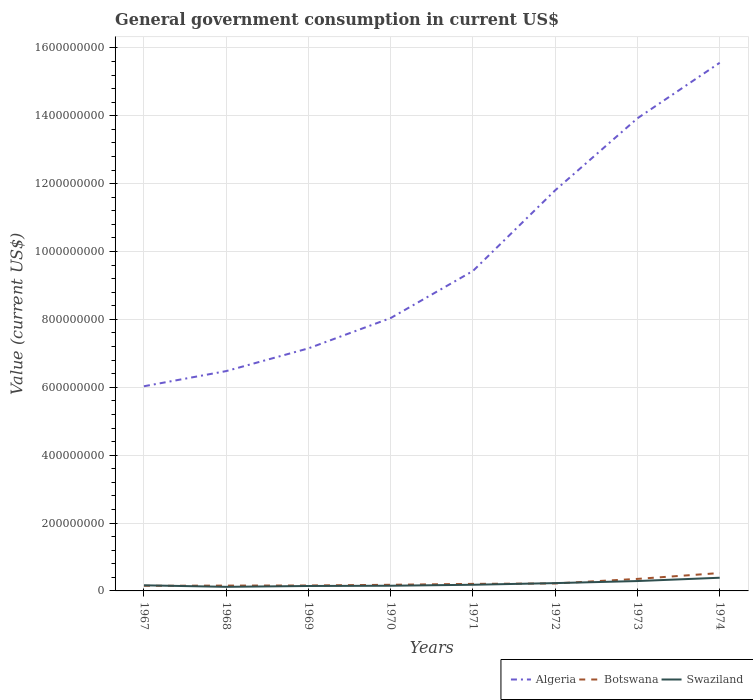How many different coloured lines are there?
Provide a short and direct response. 3. Is the number of lines equal to the number of legend labels?
Make the answer very short. Yes. Across all years, what is the maximum government conusmption in Botswana?
Provide a succinct answer. 1.51e+07. In which year was the government conusmption in Botswana maximum?
Your response must be concise. 1967. What is the total government conusmption in Botswana in the graph?
Ensure brevity in your answer.  -3.96e+06. What is the difference between the highest and the second highest government conusmption in Algeria?
Ensure brevity in your answer.  9.53e+08. How many lines are there?
Make the answer very short. 3. What is the title of the graph?
Ensure brevity in your answer.  General government consumption in current US$. Does "Panama" appear as one of the legend labels in the graph?
Your answer should be compact. No. What is the label or title of the Y-axis?
Provide a short and direct response. Value (current US$). What is the Value (current US$) in Algeria in 1967?
Your answer should be compact. 6.03e+08. What is the Value (current US$) of Botswana in 1967?
Offer a very short reply. 1.51e+07. What is the Value (current US$) of Swaziland in 1967?
Offer a very short reply. 1.65e+07. What is the Value (current US$) of Algeria in 1968?
Your response must be concise. 6.48e+08. What is the Value (current US$) of Botswana in 1968?
Provide a short and direct response. 1.57e+07. What is the Value (current US$) of Swaziland in 1968?
Make the answer very short. 1.20e+07. What is the Value (current US$) in Algeria in 1969?
Your response must be concise. 7.15e+08. What is the Value (current US$) in Botswana in 1969?
Offer a terse response. 1.60e+07. What is the Value (current US$) of Swaziland in 1969?
Make the answer very short. 1.46e+07. What is the Value (current US$) in Algeria in 1970?
Offer a terse response. 8.04e+08. What is the Value (current US$) in Botswana in 1970?
Keep it short and to the point. 1.81e+07. What is the Value (current US$) in Swaziland in 1970?
Provide a short and direct response. 1.53e+07. What is the Value (current US$) in Algeria in 1971?
Give a very brief answer. 9.43e+08. What is the Value (current US$) of Botswana in 1971?
Give a very brief answer. 2.08e+07. What is the Value (current US$) in Swaziland in 1971?
Make the answer very short. 1.82e+07. What is the Value (current US$) of Algeria in 1972?
Your answer should be very brief. 1.18e+09. What is the Value (current US$) in Botswana in 1972?
Give a very brief answer. 2.20e+07. What is the Value (current US$) in Swaziland in 1972?
Make the answer very short. 2.30e+07. What is the Value (current US$) in Algeria in 1973?
Offer a terse response. 1.39e+09. What is the Value (current US$) in Botswana in 1973?
Provide a succinct answer. 3.54e+07. What is the Value (current US$) of Swaziland in 1973?
Ensure brevity in your answer.  2.91e+07. What is the Value (current US$) in Algeria in 1974?
Give a very brief answer. 1.56e+09. What is the Value (current US$) of Botswana in 1974?
Give a very brief answer. 5.27e+07. What is the Value (current US$) in Swaziland in 1974?
Offer a terse response. 3.89e+07. Across all years, what is the maximum Value (current US$) of Algeria?
Your answer should be very brief. 1.56e+09. Across all years, what is the maximum Value (current US$) in Botswana?
Give a very brief answer. 5.27e+07. Across all years, what is the maximum Value (current US$) in Swaziland?
Keep it short and to the point. 3.89e+07. Across all years, what is the minimum Value (current US$) in Algeria?
Offer a very short reply. 6.03e+08. Across all years, what is the minimum Value (current US$) in Botswana?
Ensure brevity in your answer.  1.51e+07. Across all years, what is the minimum Value (current US$) of Swaziland?
Offer a very short reply. 1.20e+07. What is the total Value (current US$) in Algeria in the graph?
Ensure brevity in your answer.  7.84e+09. What is the total Value (current US$) in Botswana in the graph?
Give a very brief answer. 1.96e+08. What is the total Value (current US$) in Swaziland in the graph?
Provide a short and direct response. 1.68e+08. What is the difference between the Value (current US$) in Algeria in 1967 and that in 1968?
Provide a short and direct response. -4.47e+07. What is the difference between the Value (current US$) of Botswana in 1967 and that in 1968?
Keep it short and to the point. -5.59e+05. What is the difference between the Value (current US$) in Swaziland in 1967 and that in 1968?
Offer a terse response. 4.48e+06. What is the difference between the Value (current US$) in Algeria in 1967 and that in 1969?
Your answer should be very brief. -1.12e+08. What is the difference between the Value (current US$) of Botswana in 1967 and that in 1969?
Keep it short and to the point. -8.84e+05. What is the difference between the Value (current US$) in Swaziland in 1967 and that in 1969?
Make the answer very short. 1.96e+06. What is the difference between the Value (current US$) in Algeria in 1967 and that in 1970?
Ensure brevity in your answer.  -2.01e+08. What is the difference between the Value (current US$) of Botswana in 1967 and that in 1970?
Ensure brevity in your answer.  -2.94e+06. What is the difference between the Value (current US$) in Swaziland in 1967 and that in 1970?
Make the answer very short. 1.26e+06. What is the difference between the Value (current US$) of Algeria in 1967 and that in 1971?
Your answer should be very brief. -3.40e+08. What is the difference between the Value (current US$) of Botswana in 1967 and that in 1971?
Give a very brief answer. -5.63e+06. What is the difference between the Value (current US$) in Swaziland in 1967 and that in 1971?
Give a very brief answer. -1.66e+06. What is the difference between the Value (current US$) of Algeria in 1967 and that in 1972?
Offer a terse response. -5.77e+08. What is the difference between the Value (current US$) of Botswana in 1967 and that in 1972?
Ensure brevity in your answer.  -6.91e+06. What is the difference between the Value (current US$) of Swaziland in 1967 and that in 1972?
Provide a short and direct response. -6.51e+06. What is the difference between the Value (current US$) of Algeria in 1967 and that in 1973?
Make the answer very short. -7.90e+08. What is the difference between the Value (current US$) of Botswana in 1967 and that in 1973?
Offer a terse response. -2.03e+07. What is the difference between the Value (current US$) of Swaziland in 1967 and that in 1973?
Ensure brevity in your answer.  -1.26e+07. What is the difference between the Value (current US$) in Algeria in 1967 and that in 1974?
Make the answer very short. -9.53e+08. What is the difference between the Value (current US$) in Botswana in 1967 and that in 1974?
Keep it short and to the point. -3.76e+07. What is the difference between the Value (current US$) of Swaziland in 1967 and that in 1974?
Offer a very short reply. -2.23e+07. What is the difference between the Value (current US$) of Algeria in 1968 and that in 1969?
Keep it short and to the point. -6.70e+07. What is the difference between the Value (current US$) in Botswana in 1968 and that in 1969?
Keep it short and to the point. -3.25e+05. What is the difference between the Value (current US$) of Swaziland in 1968 and that in 1969?
Your answer should be very brief. -2.52e+06. What is the difference between the Value (current US$) of Algeria in 1968 and that in 1970?
Your answer should be very brief. -1.56e+08. What is the difference between the Value (current US$) of Botswana in 1968 and that in 1970?
Your answer should be compact. -2.39e+06. What is the difference between the Value (current US$) in Swaziland in 1968 and that in 1970?
Keep it short and to the point. -3.22e+06. What is the difference between the Value (current US$) of Algeria in 1968 and that in 1971?
Provide a short and direct response. -2.95e+08. What is the difference between the Value (current US$) in Botswana in 1968 and that in 1971?
Your response must be concise. -5.07e+06. What is the difference between the Value (current US$) in Swaziland in 1968 and that in 1971?
Make the answer very short. -6.14e+06. What is the difference between the Value (current US$) in Algeria in 1968 and that in 1972?
Provide a short and direct response. -5.33e+08. What is the difference between the Value (current US$) in Botswana in 1968 and that in 1972?
Ensure brevity in your answer.  -6.35e+06. What is the difference between the Value (current US$) of Swaziland in 1968 and that in 1972?
Your answer should be very brief. -1.10e+07. What is the difference between the Value (current US$) in Algeria in 1968 and that in 1973?
Your answer should be very brief. -7.45e+08. What is the difference between the Value (current US$) in Botswana in 1968 and that in 1973?
Give a very brief answer. -1.98e+07. What is the difference between the Value (current US$) of Swaziland in 1968 and that in 1973?
Your response must be concise. -1.71e+07. What is the difference between the Value (current US$) in Algeria in 1968 and that in 1974?
Provide a short and direct response. -9.08e+08. What is the difference between the Value (current US$) in Botswana in 1968 and that in 1974?
Your answer should be compact. -3.70e+07. What is the difference between the Value (current US$) of Swaziland in 1968 and that in 1974?
Offer a very short reply. -2.68e+07. What is the difference between the Value (current US$) in Algeria in 1969 and that in 1970?
Ensure brevity in your answer.  -8.93e+07. What is the difference between the Value (current US$) in Botswana in 1969 and that in 1970?
Offer a terse response. -2.06e+06. What is the difference between the Value (current US$) of Swaziland in 1969 and that in 1970?
Give a very brief answer. -7.00e+05. What is the difference between the Value (current US$) in Algeria in 1969 and that in 1971?
Provide a short and direct response. -2.28e+08. What is the difference between the Value (current US$) of Botswana in 1969 and that in 1971?
Offer a very short reply. -4.75e+06. What is the difference between the Value (current US$) in Swaziland in 1969 and that in 1971?
Your response must be concise. -3.62e+06. What is the difference between the Value (current US$) in Algeria in 1969 and that in 1972?
Give a very brief answer. -4.66e+08. What is the difference between the Value (current US$) in Botswana in 1969 and that in 1972?
Offer a very short reply. -6.02e+06. What is the difference between the Value (current US$) in Swaziland in 1969 and that in 1972?
Give a very brief answer. -8.47e+06. What is the difference between the Value (current US$) of Algeria in 1969 and that in 1973?
Make the answer very short. -6.78e+08. What is the difference between the Value (current US$) of Botswana in 1969 and that in 1973?
Offer a terse response. -1.94e+07. What is the difference between the Value (current US$) in Swaziland in 1969 and that in 1973?
Your response must be concise. -1.45e+07. What is the difference between the Value (current US$) of Algeria in 1969 and that in 1974?
Offer a terse response. -8.41e+08. What is the difference between the Value (current US$) in Botswana in 1969 and that in 1974?
Offer a terse response. -3.67e+07. What is the difference between the Value (current US$) in Swaziland in 1969 and that in 1974?
Provide a succinct answer. -2.43e+07. What is the difference between the Value (current US$) in Algeria in 1970 and that in 1971?
Make the answer very short. -1.39e+08. What is the difference between the Value (current US$) of Botswana in 1970 and that in 1971?
Make the answer very short. -2.69e+06. What is the difference between the Value (current US$) of Swaziland in 1970 and that in 1971?
Provide a short and direct response. -2.92e+06. What is the difference between the Value (current US$) in Algeria in 1970 and that in 1972?
Offer a very short reply. -3.76e+08. What is the difference between the Value (current US$) in Botswana in 1970 and that in 1972?
Offer a very short reply. -3.96e+06. What is the difference between the Value (current US$) of Swaziland in 1970 and that in 1972?
Provide a short and direct response. -7.77e+06. What is the difference between the Value (current US$) of Algeria in 1970 and that in 1973?
Keep it short and to the point. -5.89e+08. What is the difference between the Value (current US$) of Botswana in 1970 and that in 1973?
Give a very brief answer. -1.74e+07. What is the difference between the Value (current US$) in Swaziland in 1970 and that in 1973?
Ensure brevity in your answer.  -1.38e+07. What is the difference between the Value (current US$) of Algeria in 1970 and that in 1974?
Your answer should be compact. -7.52e+08. What is the difference between the Value (current US$) of Botswana in 1970 and that in 1974?
Give a very brief answer. -3.46e+07. What is the difference between the Value (current US$) in Swaziland in 1970 and that in 1974?
Ensure brevity in your answer.  -2.36e+07. What is the difference between the Value (current US$) in Algeria in 1971 and that in 1972?
Provide a short and direct response. -2.38e+08. What is the difference between the Value (current US$) of Botswana in 1971 and that in 1972?
Your response must be concise. -1.28e+06. What is the difference between the Value (current US$) in Swaziland in 1971 and that in 1972?
Offer a terse response. -4.85e+06. What is the difference between the Value (current US$) of Algeria in 1971 and that in 1973?
Your answer should be compact. -4.50e+08. What is the difference between the Value (current US$) of Botswana in 1971 and that in 1973?
Give a very brief answer. -1.47e+07. What is the difference between the Value (current US$) in Swaziland in 1971 and that in 1973?
Give a very brief answer. -1.09e+07. What is the difference between the Value (current US$) in Algeria in 1971 and that in 1974?
Ensure brevity in your answer.  -6.13e+08. What is the difference between the Value (current US$) in Botswana in 1971 and that in 1974?
Your response must be concise. -3.19e+07. What is the difference between the Value (current US$) in Swaziland in 1971 and that in 1974?
Ensure brevity in your answer.  -2.07e+07. What is the difference between the Value (current US$) in Algeria in 1972 and that in 1973?
Keep it short and to the point. -2.12e+08. What is the difference between the Value (current US$) in Botswana in 1972 and that in 1973?
Your response must be concise. -1.34e+07. What is the difference between the Value (current US$) in Swaziland in 1972 and that in 1973?
Keep it short and to the point. -6.08e+06. What is the difference between the Value (current US$) in Algeria in 1972 and that in 1974?
Your answer should be compact. -3.76e+08. What is the difference between the Value (current US$) of Botswana in 1972 and that in 1974?
Give a very brief answer. -3.06e+07. What is the difference between the Value (current US$) of Swaziland in 1972 and that in 1974?
Your answer should be compact. -1.58e+07. What is the difference between the Value (current US$) in Algeria in 1973 and that in 1974?
Keep it short and to the point. -1.64e+08. What is the difference between the Value (current US$) of Botswana in 1973 and that in 1974?
Keep it short and to the point. -1.72e+07. What is the difference between the Value (current US$) in Swaziland in 1973 and that in 1974?
Offer a very short reply. -9.75e+06. What is the difference between the Value (current US$) in Algeria in 1967 and the Value (current US$) in Botswana in 1968?
Your answer should be compact. 5.87e+08. What is the difference between the Value (current US$) in Algeria in 1967 and the Value (current US$) in Swaziland in 1968?
Ensure brevity in your answer.  5.91e+08. What is the difference between the Value (current US$) of Botswana in 1967 and the Value (current US$) of Swaziland in 1968?
Your answer should be compact. 3.09e+06. What is the difference between the Value (current US$) of Algeria in 1967 and the Value (current US$) of Botswana in 1969?
Make the answer very short. 5.87e+08. What is the difference between the Value (current US$) in Algeria in 1967 and the Value (current US$) in Swaziland in 1969?
Provide a short and direct response. 5.88e+08. What is the difference between the Value (current US$) of Botswana in 1967 and the Value (current US$) of Swaziland in 1969?
Your response must be concise. 5.71e+05. What is the difference between the Value (current US$) in Algeria in 1967 and the Value (current US$) in Botswana in 1970?
Keep it short and to the point. 5.85e+08. What is the difference between the Value (current US$) in Algeria in 1967 and the Value (current US$) in Swaziland in 1970?
Offer a terse response. 5.88e+08. What is the difference between the Value (current US$) in Botswana in 1967 and the Value (current US$) in Swaziland in 1970?
Ensure brevity in your answer.  -1.29e+05. What is the difference between the Value (current US$) of Algeria in 1967 and the Value (current US$) of Botswana in 1971?
Provide a succinct answer. 5.82e+08. What is the difference between the Value (current US$) of Algeria in 1967 and the Value (current US$) of Swaziland in 1971?
Make the answer very short. 5.85e+08. What is the difference between the Value (current US$) of Botswana in 1967 and the Value (current US$) of Swaziland in 1971?
Provide a short and direct response. -3.04e+06. What is the difference between the Value (current US$) in Algeria in 1967 and the Value (current US$) in Botswana in 1972?
Give a very brief answer. 5.81e+08. What is the difference between the Value (current US$) of Algeria in 1967 and the Value (current US$) of Swaziland in 1972?
Your response must be concise. 5.80e+08. What is the difference between the Value (current US$) in Botswana in 1967 and the Value (current US$) in Swaziland in 1972?
Provide a short and direct response. -7.89e+06. What is the difference between the Value (current US$) in Algeria in 1967 and the Value (current US$) in Botswana in 1973?
Your response must be concise. 5.68e+08. What is the difference between the Value (current US$) of Algeria in 1967 and the Value (current US$) of Swaziland in 1973?
Provide a short and direct response. 5.74e+08. What is the difference between the Value (current US$) in Botswana in 1967 and the Value (current US$) in Swaziland in 1973?
Give a very brief answer. -1.40e+07. What is the difference between the Value (current US$) of Algeria in 1967 and the Value (current US$) of Botswana in 1974?
Provide a succinct answer. 5.50e+08. What is the difference between the Value (current US$) in Algeria in 1967 and the Value (current US$) in Swaziland in 1974?
Your response must be concise. 5.64e+08. What is the difference between the Value (current US$) of Botswana in 1967 and the Value (current US$) of Swaziland in 1974?
Your answer should be very brief. -2.37e+07. What is the difference between the Value (current US$) in Algeria in 1968 and the Value (current US$) in Botswana in 1969?
Offer a terse response. 6.32e+08. What is the difference between the Value (current US$) in Algeria in 1968 and the Value (current US$) in Swaziland in 1969?
Your answer should be very brief. 6.33e+08. What is the difference between the Value (current US$) of Botswana in 1968 and the Value (current US$) of Swaziland in 1969?
Offer a very short reply. 1.13e+06. What is the difference between the Value (current US$) in Algeria in 1968 and the Value (current US$) in Botswana in 1970?
Provide a short and direct response. 6.30e+08. What is the difference between the Value (current US$) in Algeria in 1968 and the Value (current US$) in Swaziland in 1970?
Offer a very short reply. 6.32e+08. What is the difference between the Value (current US$) in Botswana in 1968 and the Value (current US$) in Swaziland in 1970?
Offer a very short reply. 4.30e+05. What is the difference between the Value (current US$) of Algeria in 1968 and the Value (current US$) of Botswana in 1971?
Your response must be concise. 6.27e+08. What is the difference between the Value (current US$) of Algeria in 1968 and the Value (current US$) of Swaziland in 1971?
Your answer should be very brief. 6.30e+08. What is the difference between the Value (current US$) of Botswana in 1968 and the Value (current US$) of Swaziland in 1971?
Provide a short and direct response. -2.49e+06. What is the difference between the Value (current US$) of Algeria in 1968 and the Value (current US$) of Botswana in 1972?
Make the answer very short. 6.26e+08. What is the difference between the Value (current US$) in Algeria in 1968 and the Value (current US$) in Swaziland in 1972?
Your answer should be compact. 6.25e+08. What is the difference between the Value (current US$) of Botswana in 1968 and the Value (current US$) of Swaziland in 1972?
Your answer should be compact. -7.34e+06. What is the difference between the Value (current US$) in Algeria in 1968 and the Value (current US$) in Botswana in 1973?
Your answer should be compact. 6.12e+08. What is the difference between the Value (current US$) of Algeria in 1968 and the Value (current US$) of Swaziland in 1973?
Your response must be concise. 6.19e+08. What is the difference between the Value (current US$) of Botswana in 1968 and the Value (current US$) of Swaziland in 1973?
Provide a short and direct response. -1.34e+07. What is the difference between the Value (current US$) in Algeria in 1968 and the Value (current US$) in Botswana in 1974?
Keep it short and to the point. 5.95e+08. What is the difference between the Value (current US$) in Algeria in 1968 and the Value (current US$) in Swaziland in 1974?
Your answer should be compact. 6.09e+08. What is the difference between the Value (current US$) in Botswana in 1968 and the Value (current US$) in Swaziland in 1974?
Make the answer very short. -2.32e+07. What is the difference between the Value (current US$) in Algeria in 1969 and the Value (current US$) in Botswana in 1970?
Ensure brevity in your answer.  6.97e+08. What is the difference between the Value (current US$) of Algeria in 1969 and the Value (current US$) of Swaziland in 1970?
Make the answer very short. 6.99e+08. What is the difference between the Value (current US$) of Botswana in 1969 and the Value (current US$) of Swaziland in 1970?
Keep it short and to the point. 7.55e+05. What is the difference between the Value (current US$) of Algeria in 1969 and the Value (current US$) of Botswana in 1971?
Make the answer very short. 6.94e+08. What is the difference between the Value (current US$) in Algeria in 1969 and the Value (current US$) in Swaziland in 1971?
Give a very brief answer. 6.97e+08. What is the difference between the Value (current US$) in Botswana in 1969 and the Value (current US$) in Swaziland in 1971?
Provide a short and direct response. -2.16e+06. What is the difference between the Value (current US$) in Algeria in 1969 and the Value (current US$) in Botswana in 1972?
Your answer should be very brief. 6.93e+08. What is the difference between the Value (current US$) in Algeria in 1969 and the Value (current US$) in Swaziland in 1972?
Offer a terse response. 6.92e+08. What is the difference between the Value (current US$) of Botswana in 1969 and the Value (current US$) of Swaziland in 1972?
Offer a very short reply. -7.01e+06. What is the difference between the Value (current US$) in Algeria in 1969 and the Value (current US$) in Botswana in 1973?
Keep it short and to the point. 6.79e+08. What is the difference between the Value (current US$) in Algeria in 1969 and the Value (current US$) in Swaziland in 1973?
Ensure brevity in your answer.  6.86e+08. What is the difference between the Value (current US$) of Botswana in 1969 and the Value (current US$) of Swaziland in 1973?
Offer a very short reply. -1.31e+07. What is the difference between the Value (current US$) of Algeria in 1969 and the Value (current US$) of Botswana in 1974?
Your answer should be compact. 6.62e+08. What is the difference between the Value (current US$) of Algeria in 1969 and the Value (current US$) of Swaziland in 1974?
Offer a terse response. 6.76e+08. What is the difference between the Value (current US$) in Botswana in 1969 and the Value (current US$) in Swaziland in 1974?
Keep it short and to the point. -2.28e+07. What is the difference between the Value (current US$) of Algeria in 1970 and the Value (current US$) of Botswana in 1971?
Your answer should be very brief. 7.83e+08. What is the difference between the Value (current US$) of Algeria in 1970 and the Value (current US$) of Swaziland in 1971?
Offer a terse response. 7.86e+08. What is the difference between the Value (current US$) of Botswana in 1970 and the Value (current US$) of Swaziland in 1971?
Provide a succinct answer. -1.00e+05. What is the difference between the Value (current US$) of Algeria in 1970 and the Value (current US$) of Botswana in 1972?
Give a very brief answer. 7.82e+08. What is the difference between the Value (current US$) in Algeria in 1970 and the Value (current US$) in Swaziland in 1972?
Provide a short and direct response. 7.81e+08. What is the difference between the Value (current US$) of Botswana in 1970 and the Value (current US$) of Swaziland in 1972?
Your answer should be compact. -4.95e+06. What is the difference between the Value (current US$) of Algeria in 1970 and the Value (current US$) of Botswana in 1973?
Make the answer very short. 7.69e+08. What is the difference between the Value (current US$) of Algeria in 1970 and the Value (current US$) of Swaziland in 1973?
Ensure brevity in your answer.  7.75e+08. What is the difference between the Value (current US$) in Botswana in 1970 and the Value (current US$) in Swaziland in 1973?
Keep it short and to the point. -1.10e+07. What is the difference between the Value (current US$) of Algeria in 1970 and the Value (current US$) of Botswana in 1974?
Ensure brevity in your answer.  7.51e+08. What is the difference between the Value (current US$) of Algeria in 1970 and the Value (current US$) of Swaziland in 1974?
Give a very brief answer. 7.65e+08. What is the difference between the Value (current US$) of Botswana in 1970 and the Value (current US$) of Swaziland in 1974?
Give a very brief answer. -2.08e+07. What is the difference between the Value (current US$) in Algeria in 1971 and the Value (current US$) in Botswana in 1972?
Offer a very short reply. 9.21e+08. What is the difference between the Value (current US$) in Algeria in 1971 and the Value (current US$) in Swaziland in 1972?
Offer a terse response. 9.20e+08. What is the difference between the Value (current US$) of Botswana in 1971 and the Value (current US$) of Swaziland in 1972?
Ensure brevity in your answer.  -2.26e+06. What is the difference between the Value (current US$) of Algeria in 1971 and the Value (current US$) of Botswana in 1973?
Ensure brevity in your answer.  9.07e+08. What is the difference between the Value (current US$) of Algeria in 1971 and the Value (current US$) of Swaziland in 1973?
Provide a succinct answer. 9.14e+08. What is the difference between the Value (current US$) in Botswana in 1971 and the Value (current US$) in Swaziland in 1973?
Make the answer very short. -8.35e+06. What is the difference between the Value (current US$) of Algeria in 1971 and the Value (current US$) of Botswana in 1974?
Offer a terse response. 8.90e+08. What is the difference between the Value (current US$) in Algeria in 1971 and the Value (current US$) in Swaziland in 1974?
Keep it short and to the point. 9.04e+08. What is the difference between the Value (current US$) of Botswana in 1971 and the Value (current US$) of Swaziland in 1974?
Keep it short and to the point. -1.81e+07. What is the difference between the Value (current US$) of Algeria in 1972 and the Value (current US$) of Botswana in 1973?
Your answer should be compact. 1.14e+09. What is the difference between the Value (current US$) of Algeria in 1972 and the Value (current US$) of Swaziland in 1973?
Ensure brevity in your answer.  1.15e+09. What is the difference between the Value (current US$) of Botswana in 1972 and the Value (current US$) of Swaziland in 1973?
Give a very brief answer. -7.07e+06. What is the difference between the Value (current US$) in Algeria in 1972 and the Value (current US$) in Botswana in 1974?
Make the answer very short. 1.13e+09. What is the difference between the Value (current US$) in Algeria in 1972 and the Value (current US$) in Swaziland in 1974?
Your answer should be very brief. 1.14e+09. What is the difference between the Value (current US$) in Botswana in 1972 and the Value (current US$) in Swaziland in 1974?
Offer a terse response. -1.68e+07. What is the difference between the Value (current US$) of Algeria in 1973 and the Value (current US$) of Botswana in 1974?
Give a very brief answer. 1.34e+09. What is the difference between the Value (current US$) of Algeria in 1973 and the Value (current US$) of Swaziland in 1974?
Provide a short and direct response. 1.35e+09. What is the difference between the Value (current US$) in Botswana in 1973 and the Value (current US$) in Swaziland in 1974?
Provide a succinct answer. -3.41e+06. What is the average Value (current US$) in Algeria per year?
Keep it short and to the point. 9.80e+08. What is the average Value (current US$) of Botswana per year?
Your response must be concise. 2.45e+07. What is the average Value (current US$) in Swaziland per year?
Your answer should be very brief. 2.09e+07. In the year 1967, what is the difference between the Value (current US$) in Algeria and Value (current US$) in Botswana?
Provide a succinct answer. 5.88e+08. In the year 1967, what is the difference between the Value (current US$) of Algeria and Value (current US$) of Swaziland?
Give a very brief answer. 5.87e+08. In the year 1967, what is the difference between the Value (current US$) in Botswana and Value (current US$) in Swaziland?
Offer a very short reply. -1.39e+06. In the year 1968, what is the difference between the Value (current US$) of Algeria and Value (current US$) of Botswana?
Your answer should be very brief. 6.32e+08. In the year 1968, what is the difference between the Value (current US$) of Algeria and Value (current US$) of Swaziland?
Provide a succinct answer. 6.36e+08. In the year 1968, what is the difference between the Value (current US$) of Botswana and Value (current US$) of Swaziland?
Offer a very short reply. 3.65e+06. In the year 1969, what is the difference between the Value (current US$) of Algeria and Value (current US$) of Botswana?
Offer a terse response. 6.99e+08. In the year 1969, what is the difference between the Value (current US$) in Algeria and Value (current US$) in Swaziland?
Offer a very short reply. 7.00e+08. In the year 1969, what is the difference between the Value (current US$) in Botswana and Value (current US$) in Swaziland?
Offer a terse response. 1.46e+06. In the year 1970, what is the difference between the Value (current US$) in Algeria and Value (current US$) in Botswana?
Give a very brief answer. 7.86e+08. In the year 1970, what is the difference between the Value (current US$) in Algeria and Value (current US$) in Swaziland?
Offer a terse response. 7.89e+08. In the year 1970, what is the difference between the Value (current US$) of Botswana and Value (current US$) of Swaziland?
Provide a succinct answer. 2.82e+06. In the year 1971, what is the difference between the Value (current US$) of Algeria and Value (current US$) of Botswana?
Give a very brief answer. 9.22e+08. In the year 1971, what is the difference between the Value (current US$) in Algeria and Value (current US$) in Swaziland?
Ensure brevity in your answer.  9.25e+08. In the year 1971, what is the difference between the Value (current US$) of Botswana and Value (current US$) of Swaziland?
Your response must be concise. 2.59e+06. In the year 1972, what is the difference between the Value (current US$) of Algeria and Value (current US$) of Botswana?
Your answer should be very brief. 1.16e+09. In the year 1972, what is the difference between the Value (current US$) in Algeria and Value (current US$) in Swaziland?
Offer a very short reply. 1.16e+09. In the year 1972, what is the difference between the Value (current US$) in Botswana and Value (current US$) in Swaziland?
Give a very brief answer. -9.88e+05. In the year 1973, what is the difference between the Value (current US$) of Algeria and Value (current US$) of Botswana?
Ensure brevity in your answer.  1.36e+09. In the year 1973, what is the difference between the Value (current US$) in Algeria and Value (current US$) in Swaziland?
Your answer should be compact. 1.36e+09. In the year 1973, what is the difference between the Value (current US$) in Botswana and Value (current US$) in Swaziland?
Ensure brevity in your answer.  6.33e+06. In the year 1974, what is the difference between the Value (current US$) in Algeria and Value (current US$) in Botswana?
Your response must be concise. 1.50e+09. In the year 1974, what is the difference between the Value (current US$) of Algeria and Value (current US$) of Swaziland?
Your answer should be very brief. 1.52e+09. In the year 1974, what is the difference between the Value (current US$) of Botswana and Value (current US$) of Swaziland?
Ensure brevity in your answer.  1.38e+07. What is the ratio of the Value (current US$) in Botswana in 1967 to that in 1968?
Give a very brief answer. 0.96. What is the ratio of the Value (current US$) in Swaziland in 1967 to that in 1968?
Your answer should be very brief. 1.37. What is the ratio of the Value (current US$) of Algeria in 1967 to that in 1969?
Ensure brevity in your answer.  0.84. What is the ratio of the Value (current US$) of Botswana in 1967 to that in 1969?
Your answer should be compact. 0.94. What is the ratio of the Value (current US$) of Swaziland in 1967 to that in 1969?
Your answer should be compact. 1.13. What is the ratio of the Value (current US$) of Botswana in 1967 to that in 1970?
Give a very brief answer. 0.84. What is the ratio of the Value (current US$) of Swaziland in 1967 to that in 1970?
Your response must be concise. 1.08. What is the ratio of the Value (current US$) in Algeria in 1967 to that in 1971?
Give a very brief answer. 0.64. What is the ratio of the Value (current US$) in Botswana in 1967 to that in 1971?
Offer a terse response. 0.73. What is the ratio of the Value (current US$) in Swaziland in 1967 to that in 1971?
Offer a terse response. 0.91. What is the ratio of the Value (current US$) in Algeria in 1967 to that in 1972?
Make the answer very short. 0.51. What is the ratio of the Value (current US$) of Botswana in 1967 to that in 1972?
Give a very brief answer. 0.69. What is the ratio of the Value (current US$) of Swaziland in 1967 to that in 1972?
Offer a very short reply. 0.72. What is the ratio of the Value (current US$) in Algeria in 1967 to that in 1973?
Provide a short and direct response. 0.43. What is the ratio of the Value (current US$) of Botswana in 1967 to that in 1973?
Keep it short and to the point. 0.43. What is the ratio of the Value (current US$) of Swaziland in 1967 to that in 1973?
Your answer should be very brief. 0.57. What is the ratio of the Value (current US$) in Algeria in 1967 to that in 1974?
Offer a very short reply. 0.39. What is the ratio of the Value (current US$) of Botswana in 1967 to that in 1974?
Ensure brevity in your answer.  0.29. What is the ratio of the Value (current US$) of Swaziland in 1967 to that in 1974?
Give a very brief answer. 0.43. What is the ratio of the Value (current US$) of Algeria in 1968 to that in 1969?
Your answer should be compact. 0.91. What is the ratio of the Value (current US$) in Botswana in 1968 to that in 1969?
Your answer should be compact. 0.98. What is the ratio of the Value (current US$) of Swaziland in 1968 to that in 1969?
Provide a short and direct response. 0.83. What is the ratio of the Value (current US$) in Algeria in 1968 to that in 1970?
Ensure brevity in your answer.  0.81. What is the ratio of the Value (current US$) in Botswana in 1968 to that in 1970?
Your answer should be very brief. 0.87. What is the ratio of the Value (current US$) of Swaziland in 1968 to that in 1970?
Your response must be concise. 0.79. What is the ratio of the Value (current US$) of Algeria in 1968 to that in 1971?
Ensure brevity in your answer.  0.69. What is the ratio of the Value (current US$) of Botswana in 1968 to that in 1971?
Keep it short and to the point. 0.76. What is the ratio of the Value (current US$) of Swaziland in 1968 to that in 1971?
Offer a very short reply. 0.66. What is the ratio of the Value (current US$) of Algeria in 1968 to that in 1972?
Ensure brevity in your answer.  0.55. What is the ratio of the Value (current US$) of Botswana in 1968 to that in 1972?
Keep it short and to the point. 0.71. What is the ratio of the Value (current US$) of Swaziland in 1968 to that in 1972?
Offer a very short reply. 0.52. What is the ratio of the Value (current US$) of Algeria in 1968 to that in 1973?
Your answer should be compact. 0.47. What is the ratio of the Value (current US$) of Botswana in 1968 to that in 1973?
Provide a short and direct response. 0.44. What is the ratio of the Value (current US$) of Swaziland in 1968 to that in 1973?
Make the answer very short. 0.41. What is the ratio of the Value (current US$) of Algeria in 1968 to that in 1974?
Provide a succinct answer. 0.42. What is the ratio of the Value (current US$) in Botswana in 1968 to that in 1974?
Your response must be concise. 0.3. What is the ratio of the Value (current US$) in Swaziland in 1968 to that in 1974?
Offer a terse response. 0.31. What is the ratio of the Value (current US$) in Botswana in 1969 to that in 1970?
Keep it short and to the point. 0.89. What is the ratio of the Value (current US$) in Swaziland in 1969 to that in 1970?
Ensure brevity in your answer.  0.95. What is the ratio of the Value (current US$) in Algeria in 1969 to that in 1971?
Your answer should be very brief. 0.76. What is the ratio of the Value (current US$) in Botswana in 1969 to that in 1971?
Ensure brevity in your answer.  0.77. What is the ratio of the Value (current US$) in Swaziland in 1969 to that in 1971?
Your answer should be compact. 0.8. What is the ratio of the Value (current US$) of Algeria in 1969 to that in 1972?
Provide a succinct answer. 0.61. What is the ratio of the Value (current US$) in Botswana in 1969 to that in 1972?
Provide a short and direct response. 0.73. What is the ratio of the Value (current US$) of Swaziland in 1969 to that in 1972?
Your answer should be compact. 0.63. What is the ratio of the Value (current US$) of Algeria in 1969 to that in 1973?
Your response must be concise. 0.51. What is the ratio of the Value (current US$) of Botswana in 1969 to that in 1973?
Provide a short and direct response. 0.45. What is the ratio of the Value (current US$) of Swaziland in 1969 to that in 1973?
Ensure brevity in your answer.  0.5. What is the ratio of the Value (current US$) of Algeria in 1969 to that in 1974?
Give a very brief answer. 0.46. What is the ratio of the Value (current US$) in Botswana in 1969 to that in 1974?
Give a very brief answer. 0.3. What is the ratio of the Value (current US$) of Swaziland in 1969 to that in 1974?
Offer a very short reply. 0.37. What is the ratio of the Value (current US$) in Algeria in 1970 to that in 1971?
Offer a terse response. 0.85. What is the ratio of the Value (current US$) in Botswana in 1970 to that in 1971?
Provide a short and direct response. 0.87. What is the ratio of the Value (current US$) in Swaziland in 1970 to that in 1971?
Offer a very short reply. 0.84. What is the ratio of the Value (current US$) of Algeria in 1970 to that in 1972?
Your answer should be very brief. 0.68. What is the ratio of the Value (current US$) of Botswana in 1970 to that in 1972?
Provide a short and direct response. 0.82. What is the ratio of the Value (current US$) of Swaziland in 1970 to that in 1972?
Your answer should be very brief. 0.66. What is the ratio of the Value (current US$) in Algeria in 1970 to that in 1973?
Keep it short and to the point. 0.58. What is the ratio of the Value (current US$) of Botswana in 1970 to that in 1973?
Your answer should be compact. 0.51. What is the ratio of the Value (current US$) of Swaziland in 1970 to that in 1973?
Keep it short and to the point. 0.52. What is the ratio of the Value (current US$) of Algeria in 1970 to that in 1974?
Your answer should be very brief. 0.52. What is the ratio of the Value (current US$) in Botswana in 1970 to that in 1974?
Keep it short and to the point. 0.34. What is the ratio of the Value (current US$) in Swaziland in 1970 to that in 1974?
Your answer should be very brief. 0.39. What is the ratio of the Value (current US$) in Algeria in 1971 to that in 1972?
Provide a succinct answer. 0.8. What is the ratio of the Value (current US$) in Botswana in 1971 to that in 1972?
Your answer should be very brief. 0.94. What is the ratio of the Value (current US$) in Swaziland in 1971 to that in 1972?
Your response must be concise. 0.79. What is the ratio of the Value (current US$) in Algeria in 1971 to that in 1973?
Offer a very short reply. 0.68. What is the ratio of the Value (current US$) in Botswana in 1971 to that in 1973?
Provide a succinct answer. 0.59. What is the ratio of the Value (current US$) in Swaziland in 1971 to that in 1973?
Offer a terse response. 0.62. What is the ratio of the Value (current US$) of Algeria in 1971 to that in 1974?
Your response must be concise. 0.61. What is the ratio of the Value (current US$) of Botswana in 1971 to that in 1974?
Provide a succinct answer. 0.39. What is the ratio of the Value (current US$) of Swaziland in 1971 to that in 1974?
Provide a short and direct response. 0.47. What is the ratio of the Value (current US$) in Algeria in 1972 to that in 1973?
Give a very brief answer. 0.85. What is the ratio of the Value (current US$) of Botswana in 1972 to that in 1973?
Provide a succinct answer. 0.62. What is the ratio of the Value (current US$) of Swaziland in 1972 to that in 1973?
Offer a very short reply. 0.79. What is the ratio of the Value (current US$) in Algeria in 1972 to that in 1974?
Your response must be concise. 0.76. What is the ratio of the Value (current US$) in Botswana in 1972 to that in 1974?
Your answer should be very brief. 0.42. What is the ratio of the Value (current US$) in Swaziland in 1972 to that in 1974?
Your answer should be very brief. 0.59. What is the ratio of the Value (current US$) of Algeria in 1973 to that in 1974?
Your response must be concise. 0.89. What is the ratio of the Value (current US$) in Botswana in 1973 to that in 1974?
Your answer should be very brief. 0.67. What is the ratio of the Value (current US$) in Swaziland in 1973 to that in 1974?
Ensure brevity in your answer.  0.75. What is the difference between the highest and the second highest Value (current US$) of Algeria?
Ensure brevity in your answer.  1.64e+08. What is the difference between the highest and the second highest Value (current US$) in Botswana?
Your response must be concise. 1.72e+07. What is the difference between the highest and the second highest Value (current US$) in Swaziland?
Offer a terse response. 9.75e+06. What is the difference between the highest and the lowest Value (current US$) in Algeria?
Provide a succinct answer. 9.53e+08. What is the difference between the highest and the lowest Value (current US$) of Botswana?
Keep it short and to the point. 3.76e+07. What is the difference between the highest and the lowest Value (current US$) in Swaziland?
Keep it short and to the point. 2.68e+07. 